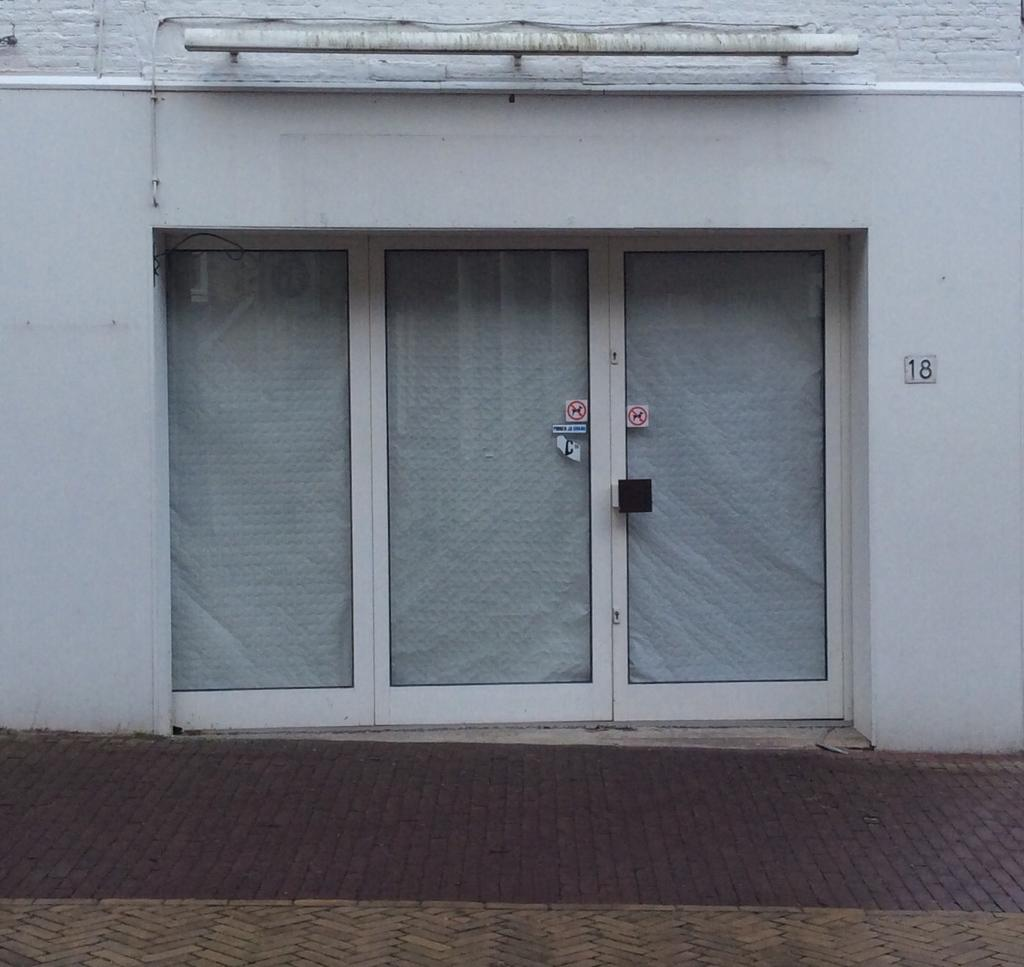Where was the image taken? The image was clicked outside. What can be seen in the foreground of the image? There is a pavement in the foreground of the image. What architectural elements of a house are visible in the image? The windows and wall of a house are visible in the center of the image. What is located at the top of the image? There is a metal rod at the top of the image. What type of flower is growing near the metal rod in the image? There are no flowers present in the image; it features a pavement, a house, and a metal rod. Can you tell me how many boots are visible in the image? There are no boots present in the image. 